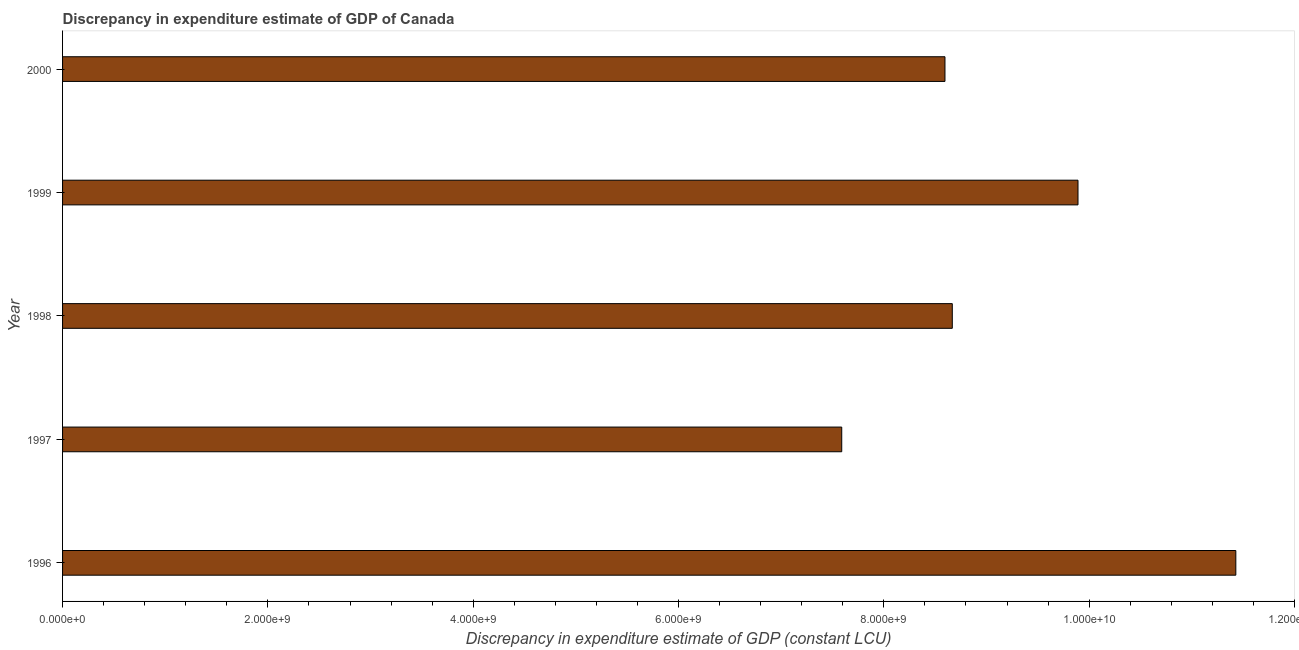Does the graph contain any zero values?
Your answer should be very brief. No. What is the title of the graph?
Your answer should be very brief. Discrepancy in expenditure estimate of GDP of Canada. What is the label or title of the X-axis?
Offer a terse response. Discrepancy in expenditure estimate of GDP (constant LCU). What is the discrepancy in expenditure estimate of gdp in 1996?
Offer a very short reply. 1.14e+1. Across all years, what is the maximum discrepancy in expenditure estimate of gdp?
Provide a succinct answer. 1.14e+1. Across all years, what is the minimum discrepancy in expenditure estimate of gdp?
Keep it short and to the point. 7.59e+09. In which year was the discrepancy in expenditure estimate of gdp minimum?
Ensure brevity in your answer.  1997. What is the sum of the discrepancy in expenditure estimate of gdp?
Make the answer very short. 4.62e+1. What is the difference between the discrepancy in expenditure estimate of gdp in 1997 and 2000?
Your response must be concise. -1.01e+09. What is the average discrepancy in expenditure estimate of gdp per year?
Provide a short and direct response. 9.23e+09. What is the median discrepancy in expenditure estimate of gdp?
Your response must be concise. 8.67e+09. What is the ratio of the discrepancy in expenditure estimate of gdp in 1998 to that in 1999?
Keep it short and to the point. 0.88. Is the discrepancy in expenditure estimate of gdp in 1999 less than that in 2000?
Provide a short and direct response. No. Is the difference between the discrepancy in expenditure estimate of gdp in 1998 and 1999 greater than the difference between any two years?
Make the answer very short. No. What is the difference between the highest and the second highest discrepancy in expenditure estimate of gdp?
Keep it short and to the point. 1.54e+09. Is the sum of the discrepancy in expenditure estimate of gdp in 1999 and 2000 greater than the maximum discrepancy in expenditure estimate of gdp across all years?
Your response must be concise. Yes. What is the difference between the highest and the lowest discrepancy in expenditure estimate of gdp?
Your answer should be very brief. 3.84e+09. In how many years, is the discrepancy in expenditure estimate of gdp greater than the average discrepancy in expenditure estimate of gdp taken over all years?
Ensure brevity in your answer.  2. Are all the bars in the graph horizontal?
Your response must be concise. Yes. How many years are there in the graph?
Make the answer very short. 5. What is the difference between two consecutive major ticks on the X-axis?
Make the answer very short. 2.00e+09. What is the Discrepancy in expenditure estimate of GDP (constant LCU) in 1996?
Your answer should be very brief. 1.14e+1. What is the Discrepancy in expenditure estimate of GDP (constant LCU) of 1997?
Your response must be concise. 7.59e+09. What is the Discrepancy in expenditure estimate of GDP (constant LCU) of 1998?
Keep it short and to the point. 8.67e+09. What is the Discrepancy in expenditure estimate of GDP (constant LCU) of 1999?
Keep it short and to the point. 9.89e+09. What is the Discrepancy in expenditure estimate of GDP (constant LCU) of 2000?
Give a very brief answer. 8.60e+09. What is the difference between the Discrepancy in expenditure estimate of GDP (constant LCU) in 1996 and 1997?
Make the answer very short. 3.84e+09. What is the difference between the Discrepancy in expenditure estimate of GDP (constant LCU) in 1996 and 1998?
Offer a terse response. 2.76e+09. What is the difference between the Discrepancy in expenditure estimate of GDP (constant LCU) in 1996 and 1999?
Make the answer very short. 1.54e+09. What is the difference between the Discrepancy in expenditure estimate of GDP (constant LCU) in 1996 and 2000?
Provide a short and direct response. 2.83e+09. What is the difference between the Discrepancy in expenditure estimate of GDP (constant LCU) in 1997 and 1998?
Make the answer very short. -1.08e+09. What is the difference between the Discrepancy in expenditure estimate of GDP (constant LCU) in 1997 and 1999?
Provide a short and direct response. -2.30e+09. What is the difference between the Discrepancy in expenditure estimate of GDP (constant LCU) in 1997 and 2000?
Give a very brief answer. -1.01e+09. What is the difference between the Discrepancy in expenditure estimate of GDP (constant LCU) in 1998 and 1999?
Your response must be concise. -1.22e+09. What is the difference between the Discrepancy in expenditure estimate of GDP (constant LCU) in 1998 and 2000?
Give a very brief answer. 7.13e+07. What is the difference between the Discrepancy in expenditure estimate of GDP (constant LCU) in 1999 and 2000?
Ensure brevity in your answer.  1.30e+09. What is the ratio of the Discrepancy in expenditure estimate of GDP (constant LCU) in 1996 to that in 1997?
Give a very brief answer. 1.51. What is the ratio of the Discrepancy in expenditure estimate of GDP (constant LCU) in 1996 to that in 1998?
Give a very brief answer. 1.32. What is the ratio of the Discrepancy in expenditure estimate of GDP (constant LCU) in 1996 to that in 1999?
Your answer should be compact. 1.16. What is the ratio of the Discrepancy in expenditure estimate of GDP (constant LCU) in 1996 to that in 2000?
Ensure brevity in your answer.  1.33. What is the ratio of the Discrepancy in expenditure estimate of GDP (constant LCU) in 1997 to that in 1998?
Keep it short and to the point. 0.88. What is the ratio of the Discrepancy in expenditure estimate of GDP (constant LCU) in 1997 to that in 1999?
Give a very brief answer. 0.77. What is the ratio of the Discrepancy in expenditure estimate of GDP (constant LCU) in 1997 to that in 2000?
Ensure brevity in your answer.  0.88. What is the ratio of the Discrepancy in expenditure estimate of GDP (constant LCU) in 1998 to that in 1999?
Ensure brevity in your answer.  0.88. What is the ratio of the Discrepancy in expenditure estimate of GDP (constant LCU) in 1999 to that in 2000?
Provide a succinct answer. 1.15. 